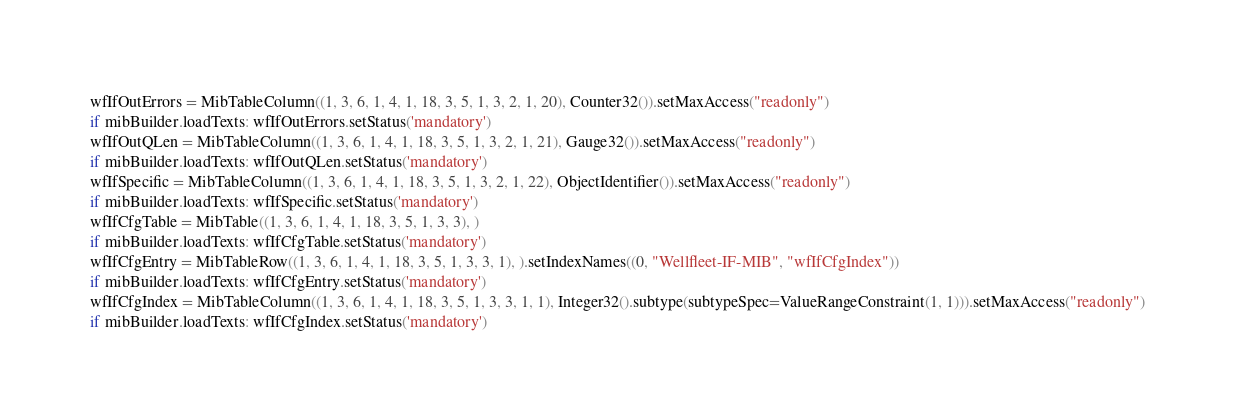Convert code to text. <code><loc_0><loc_0><loc_500><loc_500><_Python_>wfIfOutErrors = MibTableColumn((1, 3, 6, 1, 4, 1, 18, 3, 5, 1, 3, 2, 1, 20), Counter32()).setMaxAccess("readonly")
if mibBuilder.loadTexts: wfIfOutErrors.setStatus('mandatory')
wfIfOutQLen = MibTableColumn((1, 3, 6, 1, 4, 1, 18, 3, 5, 1, 3, 2, 1, 21), Gauge32()).setMaxAccess("readonly")
if mibBuilder.loadTexts: wfIfOutQLen.setStatus('mandatory')
wfIfSpecific = MibTableColumn((1, 3, 6, 1, 4, 1, 18, 3, 5, 1, 3, 2, 1, 22), ObjectIdentifier()).setMaxAccess("readonly")
if mibBuilder.loadTexts: wfIfSpecific.setStatus('mandatory')
wfIfCfgTable = MibTable((1, 3, 6, 1, 4, 1, 18, 3, 5, 1, 3, 3), )
if mibBuilder.loadTexts: wfIfCfgTable.setStatus('mandatory')
wfIfCfgEntry = MibTableRow((1, 3, 6, 1, 4, 1, 18, 3, 5, 1, 3, 3, 1), ).setIndexNames((0, "Wellfleet-IF-MIB", "wfIfCfgIndex"))
if mibBuilder.loadTexts: wfIfCfgEntry.setStatus('mandatory')
wfIfCfgIndex = MibTableColumn((1, 3, 6, 1, 4, 1, 18, 3, 5, 1, 3, 3, 1, 1), Integer32().subtype(subtypeSpec=ValueRangeConstraint(1, 1))).setMaxAccess("readonly")
if mibBuilder.loadTexts: wfIfCfgIndex.setStatus('mandatory')</code> 